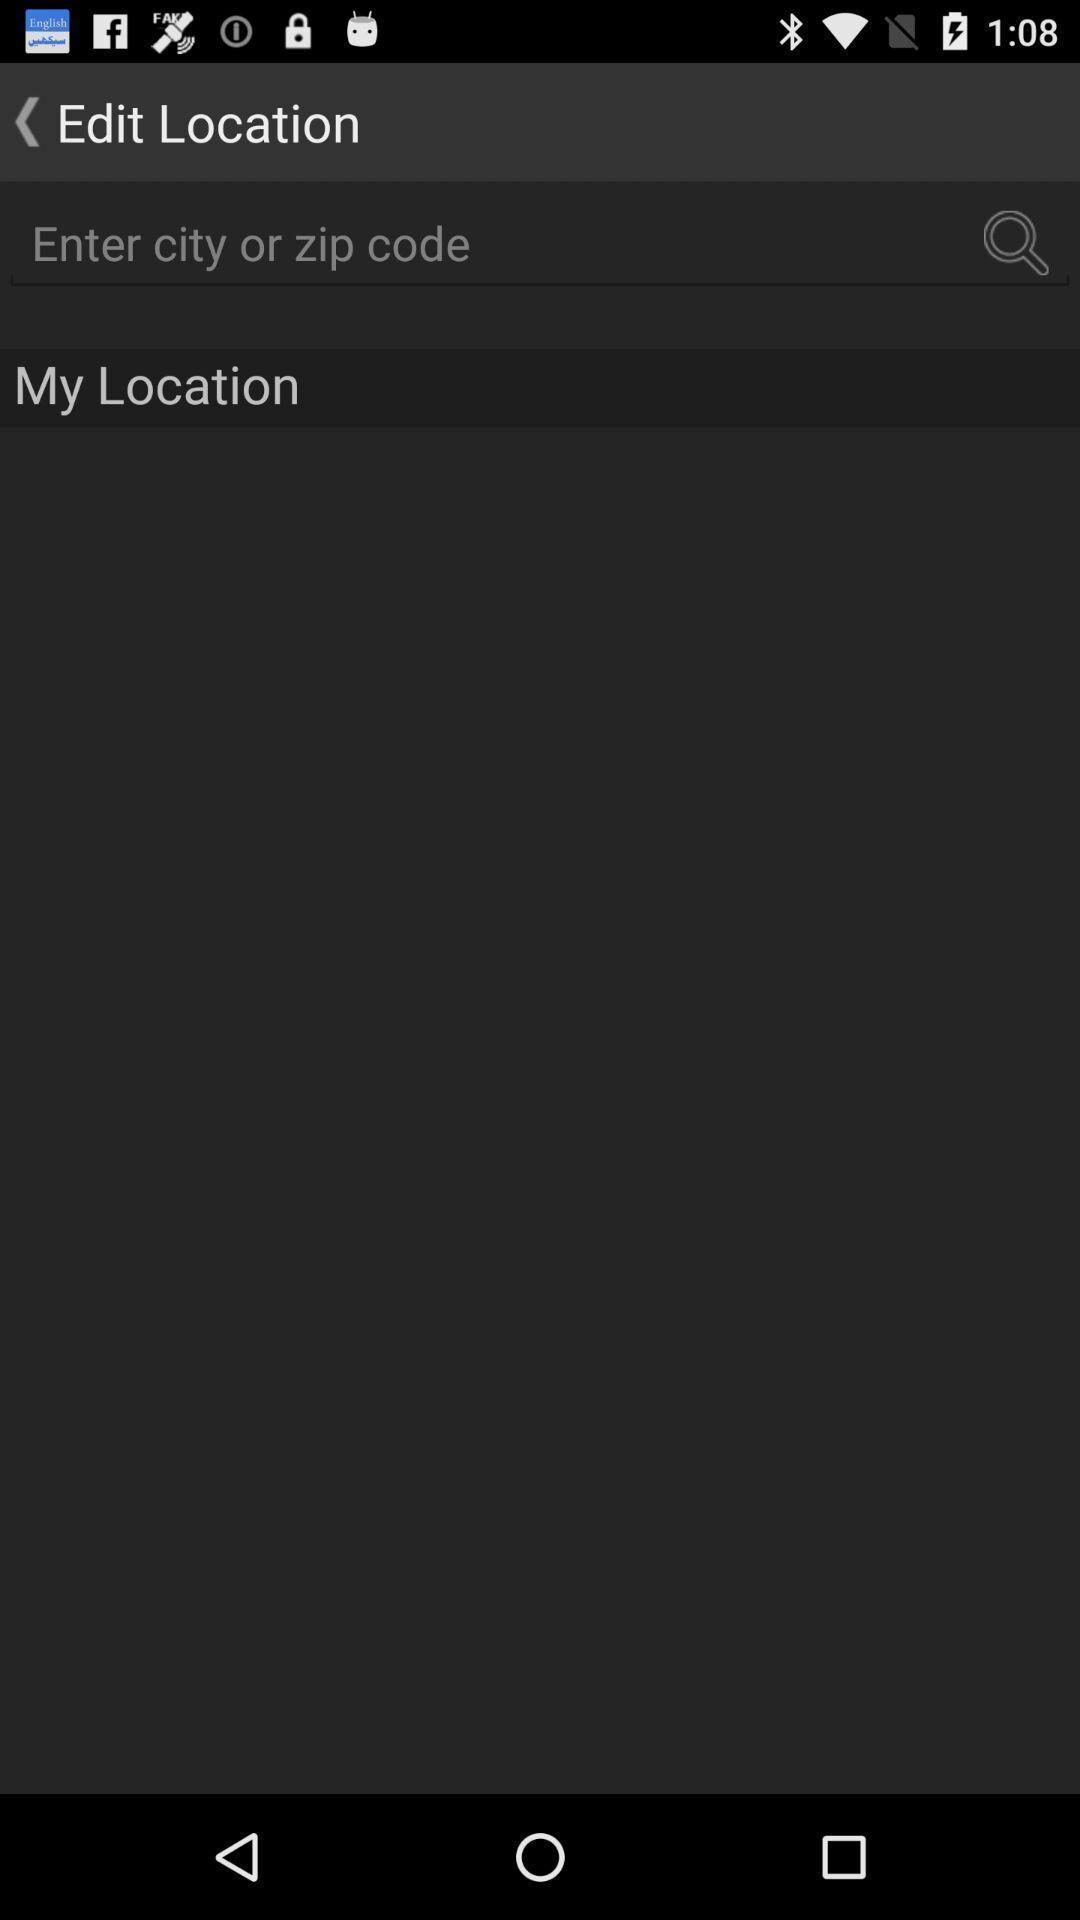Summarize the information in this screenshot. Search page to find location displayed. 